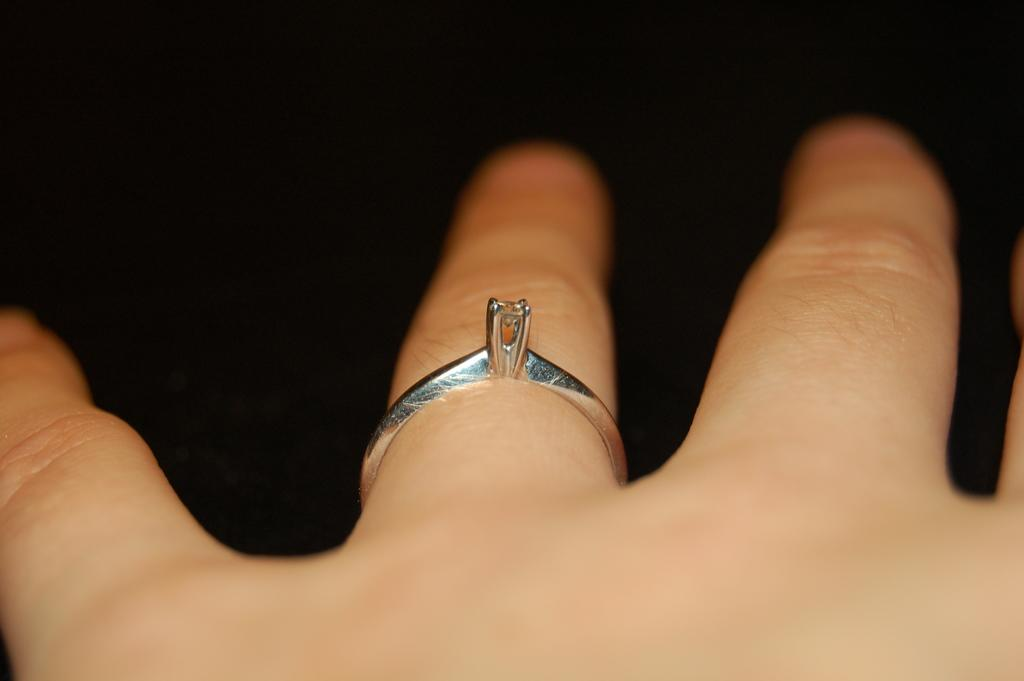What is on the finger of the person in the image? There is a ring on the finger of a person in the image. How fast does the person in the image run while wearing the boot? There is no mention of a boot or running in the image, as it only features a person with a ring on their finger. 